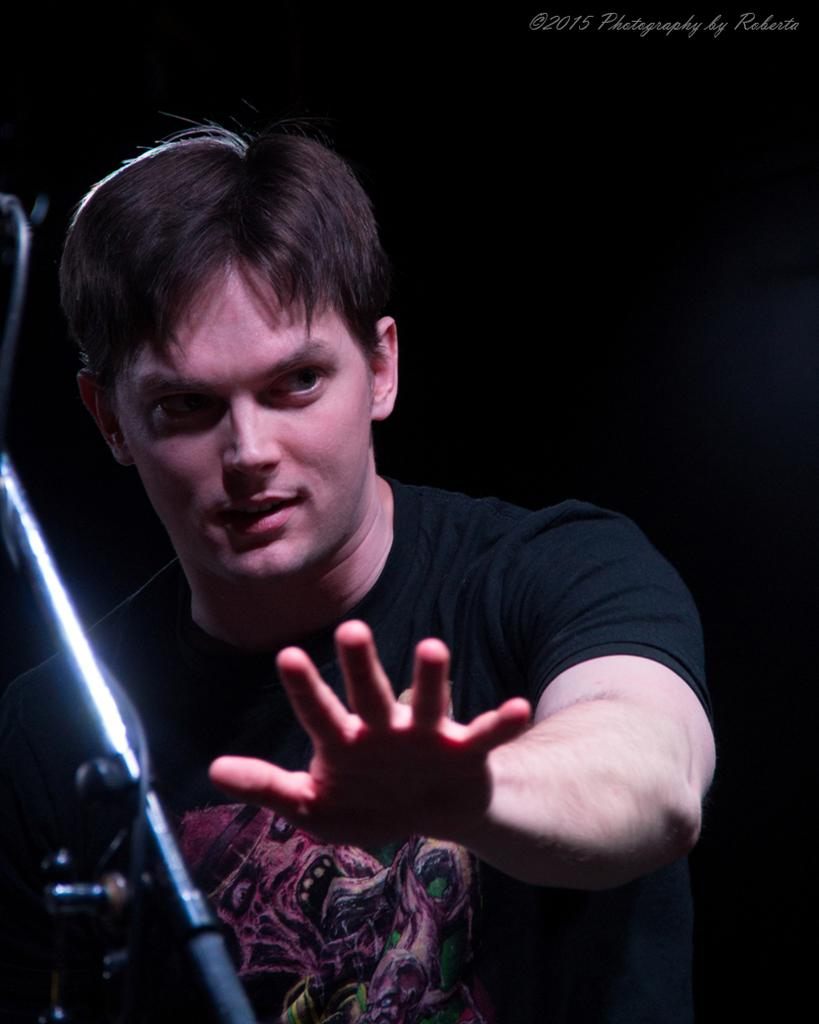Who is present in the image? There is a man in the image. What object can be seen in the image besides the man? There is a stand in the image. What can be observed about the background of the image? The background of the image is dark. Where is the text located in the image? The text is at the top of the image. What type of queen is sitting on the bed in the image? There is no queen or bed present in the image; it only features a man and a stand. Is there a bomb visible in the image? No, there is no bomb present in the image. 